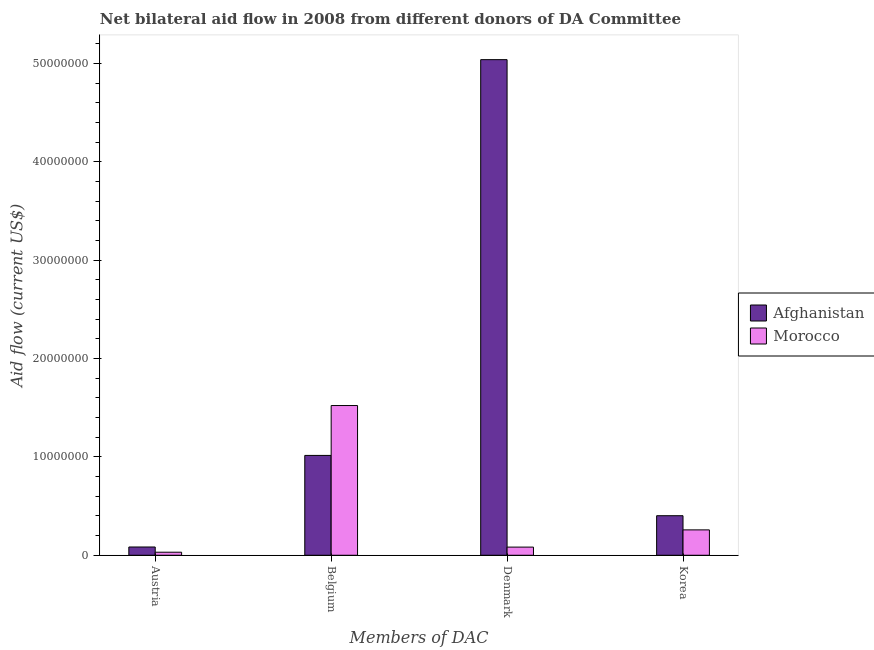How many bars are there on the 1st tick from the left?
Give a very brief answer. 2. How many bars are there on the 1st tick from the right?
Offer a very short reply. 2. What is the label of the 1st group of bars from the left?
Keep it short and to the point. Austria. What is the amount of aid given by korea in Morocco?
Provide a short and direct response. 2.58e+06. Across all countries, what is the maximum amount of aid given by belgium?
Ensure brevity in your answer.  1.52e+07. Across all countries, what is the minimum amount of aid given by belgium?
Your response must be concise. 1.02e+07. In which country was the amount of aid given by austria maximum?
Offer a terse response. Afghanistan. In which country was the amount of aid given by denmark minimum?
Your response must be concise. Morocco. What is the total amount of aid given by denmark in the graph?
Ensure brevity in your answer.  5.12e+07. What is the difference between the amount of aid given by belgium in Morocco and that in Afghanistan?
Make the answer very short. 5.07e+06. What is the difference between the amount of aid given by denmark in Afghanistan and the amount of aid given by korea in Morocco?
Provide a succinct answer. 4.78e+07. What is the average amount of aid given by korea per country?
Offer a terse response. 3.30e+06. What is the difference between the amount of aid given by korea and amount of aid given by austria in Afghanistan?
Offer a very short reply. 3.18e+06. In how many countries, is the amount of aid given by korea greater than 12000000 US$?
Your answer should be very brief. 0. What is the ratio of the amount of aid given by denmark in Morocco to that in Afghanistan?
Your response must be concise. 0.02. Is the difference between the amount of aid given by korea in Afghanistan and Morocco greater than the difference between the amount of aid given by denmark in Afghanistan and Morocco?
Provide a succinct answer. No. What is the difference between the highest and the second highest amount of aid given by korea?
Provide a succinct answer. 1.44e+06. What is the difference between the highest and the lowest amount of aid given by denmark?
Ensure brevity in your answer.  4.96e+07. In how many countries, is the amount of aid given by belgium greater than the average amount of aid given by belgium taken over all countries?
Offer a very short reply. 1. Is the sum of the amount of aid given by korea in Afghanistan and Morocco greater than the maximum amount of aid given by denmark across all countries?
Make the answer very short. No. Is it the case that in every country, the sum of the amount of aid given by belgium and amount of aid given by austria is greater than the sum of amount of aid given by korea and amount of aid given by denmark?
Offer a terse response. No. What does the 1st bar from the left in Korea represents?
Your response must be concise. Afghanistan. What does the 1st bar from the right in Austria represents?
Provide a succinct answer. Morocco. How many bars are there?
Make the answer very short. 8. Are all the bars in the graph horizontal?
Offer a very short reply. No. Are the values on the major ticks of Y-axis written in scientific E-notation?
Offer a very short reply. No. Does the graph contain grids?
Give a very brief answer. No. How are the legend labels stacked?
Your answer should be compact. Vertical. What is the title of the graph?
Provide a short and direct response. Net bilateral aid flow in 2008 from different donors of DA Committee. What is the label or title of the X-axis?
Your response must be concise. Members of DAC. What is the label or title of the Y-axis?
Give a very brief answer. Aid flow (current US$). What is the Aid flow (current US$) in Afghanistan in Austria?
Ensure brevity in your answer.  8.40e+05. What is the Aid flow (current US$) of Afghanistan in Belgium?
Give a very brief answer. 1.02e+07. What is the Aid flow (current US$) of Morocco in Belgium?
Make the answer very short. 1.52e+07. What is the Aid flow (current US$) of Afghanistan in Denmark?
Offer a very short reply. 5.04e+07. What is the Aid flow (current US$) in Morocco in Denmark?
Provide a short and direct response. 8.30e+05. What is the Aid flow (current US$) in Afghanistan in Korea?
Offer a very short reply. 4.02e+06. What is the Aid flow (current US$) of Morocco in Korea?
Offer a very short reply. 2.58e+06. Across all Members of DAC, what is the maximum Aid flow (current US$) of Afghanistan?
Your answer should be compact. 5.04e+07. Across all Members of DAC, what is the maximum Aid flow (current US$) of Morocco?
Make the answer very short. 1.52e+07. Across all Members of DAC, what is the minimum Aid flow (current US$) in Afghanistan?
Give a very brief answer. 8.40e+05. Across all Members of DAC, what is the minimum Aid flow (current US$) in Morocco?
Your answer should be very brief. 3.10e+05. What is the total Aid flow (current US$) of Afghanistan in the graph?
Offer a terse response. 6.54e+07. What is the total Aid flow (current US$) in Morocco in the graph?
Offer a very short reply. 1.89e+07. What is the difference between the Aid flow (current US$) in Afghanistan in Austria and that in Belgium?
Your answer should be compact. -9.31e+06. What is the difference between the Aid flow (current US$) of Morocco in Austria and that in Belgium?
Make the answer very short. -1.49e+07. What is the difference between the Aid flow (current US$) in Afghanistan in Austria and that in Denmark?
Provide a short and direct response. -4.95e+07. What is the difference between the Aid flow (current US$) in Morocco in Austria and that in Denmark?
Ensure brevity in your answer.  -5.20e+05. What is the difference between the Aid flow (current US$) of Afghanistan in Austria and that in Korea?
Provide a short and direct response. -3.18e+06. What is the difference between the Aid flow (current US$) in Morocco in Austria and that in Korea?
Give a very brief answer. -2.27e+06. What is the difference between the Aid flow (current US$) in Afghanistan in Belgium and that in Denmark?
Your answer should be very brief. -4.02e+07. What is the difference between the Aid flow (current US$) in Morocco in Belgium and that in Denmark?
Your response must be concise. 1.44e+07. What is the difference between the Aid flow (current US$) of Afghanistan in Belgium and that in Korea?
Your response must be concise. 6.13e+06. What is the difference between the Aid flow (current US$) of Morocco in Belgium and that in Korea?
Keep it short and to the point. 1.26e+07. What is the difference between the Aid flow (current US$) in Afghanistan in Denmark and that in Korea?
Your response must be concise. 4.64e+07. What is the difference between the Aid flow (current US$) in Morocco in Denmark and that in Korea?
Offer a terse response. -1.75e+06. What is the difference between the Aid flow (current US$) in Afghanistan in Austria and the Aid flow (current US$) in Morocco in Belgium?
Provide a short and direct response. -1.44e+07. What is the difference between the Aid flow (current US$) of Afghanistan in Austria and the Aid flow (current US$) of Morocco in Korea?
Give a very brief answer. -1.74e+06. What is the difference between the Aid flow (current US$) of Afghanistan in Belgium and the Aid flow (current US$) of Morocco in Denmark?
Give a very brief answer. 9.32e+06. What is the difference between the Aid flow (current US$) of Afghanistan in Belgium and the Aid flow (current US$) of Morocco in Korea?
Make the answer very short. 7.57e+06. What is the difference between the Aid flow (current US$) in Afghanistan in Denmark and the Aid flow (current US$) in Morocco in Korea?
Your answer should be compact. 4.78e+07. What is the average Aid flow (current US$) of Afghanistan per Members of DAC?
Offer a terse response. 1.63e+07. What is the average Aid flow (current US$) in Morocco per Members of DAC?
Offer a terse response. 4.74e+06. What is the difference between the Aid flow (current US$) in Afghanistan and Aid flow (current US$) in Morocco in Austria?
Your response must be concise. 5.30e+05. What is the difference between the Aid flow (current US$) of Afghanistan and Aid flow (current US$) of Morocco in Belgium?
Your answer should be compact. -5.07e+06. What is the difference between the Aid flow (current US$) in Afghanistan and Aid flow (current US$) in Morocco in Denmark?
Your answer should be very brief. 4.96e+07. What is the difference between the Aid flow (current US$) in Afghanistan and Aid flow (current US$) in Morocco in Korea?
Offer a terse response. 1.44e+06. What is the ratio of the Aid flow (current US$) in Afghanistan in Austria to that in Belgium?
Provide a short and direct response. 0.08. What is the ratio of the Aid flow (current US$) in Morocco in Austria to that in Belgium?
Your answer should be very brief. 0.02. What is the ratio of the Aid flow (current US$) in Afghanistan in Austria to that in Denmark?
Provide a succinct answer. 0.02. What is the ratio of the Aid flow (current US$) in Morocco in Austria to that in Denmark?
Ensure brevity in your answer.  0.37. What is the ratio of the Aid flow (current US$) of Afghanistan in Austria to that in Korea?
Your answer should be very brief. 0.21. What is the ratio of the Aid flow (current US$) of Morocco in Austria to that in Korea?
Your answer should be compact. 0.12. What is the ratio of the Aid flow (current US$) of Afghanistan in Belgium to that in Denmark?
Make the answer very short. 0.2. What is the ratio of the Aid flow (current US$) of Morocco in Belgium to that in Denmark?
Your response must be concise. 18.34. What is the ratio of the Aid flow (current US$) of Afghanistan in Belgium to that in Korea?
Offer a very short reply. 2.52. What is the ratio of the Aid flow (current US$) of Morocco in Belgium to that in Korea?
Offer a terse response. 5.9. What is the ratio of the Aid flow (current US$) in Afghanistan in Denmark to that in Korea?
Ensure brevity in your answer.  12.53. What is the ratio of the Aid flow (current US$) in Morocco in Denmark to that in Korea?
Your answer should be compact. 0.32. What is the difference between the highest and the second highest Aid flow (current US$) in Afghanistan?
Ensure brevity in your answer.  4.02e+07. What is the difference between the highest and the second highest Aid flow (current US$) in Morocco?
Your response must be concise. 1.26e+07. What is the difference between the highest and the lowest Aid flow (current US$) in Afghanistan?
Your answer should be compact. 4.95e+07. What is the difference between the highest and the lowest Aid flow (current US$) in Morocco?
Give a very brief answer. 1.49e+07. 